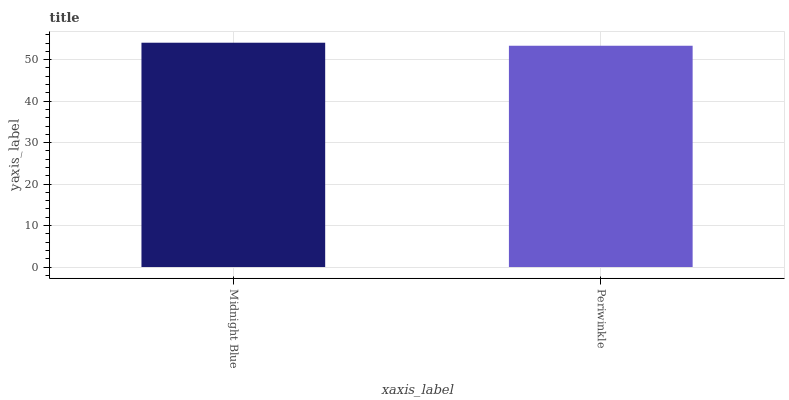Is Periwinkle the minimum?
Answer yes or no. Yes. Is Midnight Blue the maximum?
Answer yes or no. Yes. Is Periwinkle the maximum?
Answer yes or no. No. Is Midnight Blue greater than Periwinkle?
Answer yes or no. Yes. Is Periwinkle less than Midnight Blue?
Answer yes or no. Yes. Is Periwinkle greater than Midnight Blue?
Answer yes or no. No. Is Midnight Blue less than Periwinkle?
Answer yes or no. No. Is Midnight Blue the high median?
Answer yes or no. Yes. Is Periwinkle the low median?
Answer yes or no. Yes. Is Periwinkle the high median?
Answer yes or no. No. Is Midnight Blue the low median?
Answer yes or no. No. 